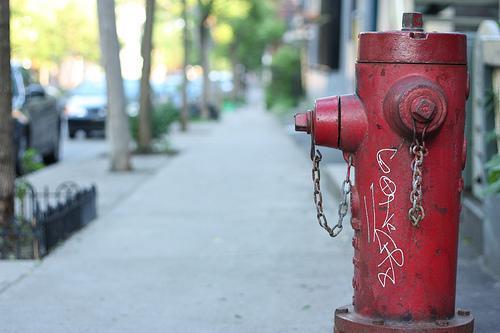How many hydrants are there?
Give a very brief answer. 1. 